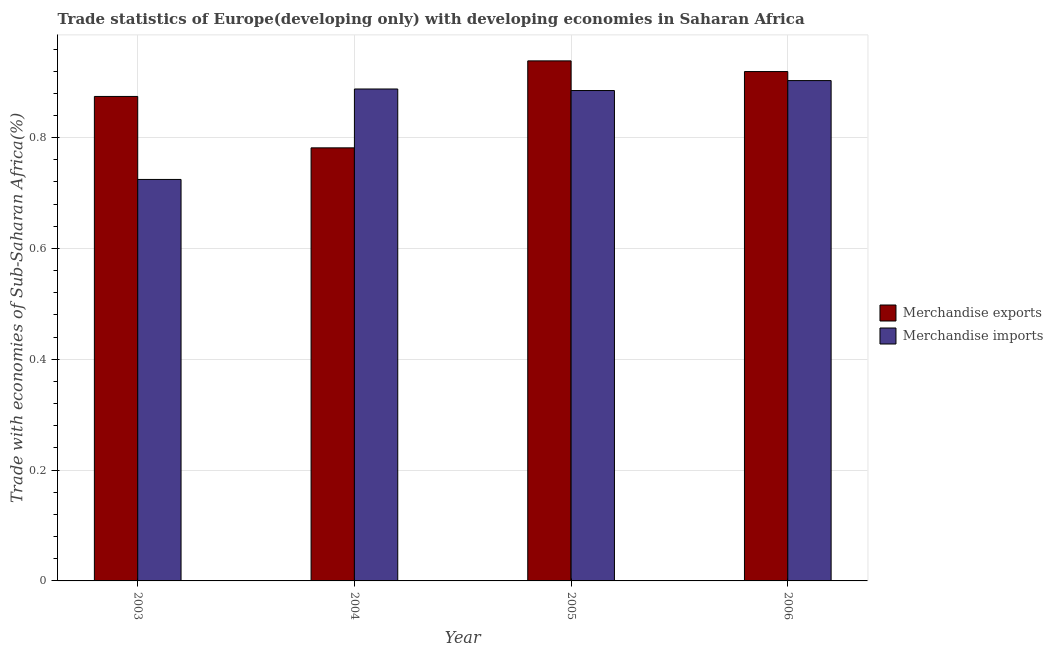How many groups of bars are there?
Provide a succinct answer. 4. Are the number of bars per tick equal to the number of legend labels?
Offer a very short reply. Yes. What is the merchandise imports in 2004?
Provide a succinct answer. 0.89. Across all years, what is the maximum merchandise exports?
Offer a very short reply. 0.94. Across all years, what is the minimum merchandise imports?
Ensure brevity in your answer.  0.72. What is the total merchandise exports in the graph?
Offer a very short reply. 3.51. What is the difference between the merchandise imports in 2004 and that in 2006?
Offer a terse response. -0.02. What is the difference between the merchandise exports in 2003 and the merchandise imports in 2004?
Provide a succinct answer. 0.09. What is the average merchandise exports per year?
Give a very brief answer. 0.88. In the year 2005, what is the difference between the merchandise exports and merchandise imports?
Make the answer very short. 0. What is the ratio of the merchandise exports in 2003 to that in 2005?
Provide a succinct answer. 0.93. Is the merchandise imports in 2005 less than that in 2006?
Your answer should be compact. Yes. What is the difference between the highest and the second highest merchandise exports?
Your answer should be very brief. 0.02. What is the difference between the highest and the lowest merchandise exports?
Your answer should be compact. 0.16. In how many years, is the merchandise imports greater than the average merchandise imports taken over all years?
Provide a short and direct response. 3. Is the sum of the merchandise exports in 2003 and 2004 greater than the maximum merchandise imports across all years?
Your answer should be very brief. Yes. What does the 2nd bar from the left in 2003 represents?
Provide a short and direct response. Merchandise imports. What does the 2nd bar from the right in 2004 represents?
Make the answer very short. Merchandise exports. Are all the bars in the graph horizontal?
Offer a very short reply. No. How many years are there in the graph?
Provide a succinct answer. 4. Does the graph contain grids?
Ensure brevity in your answer.  Yes. How many legend labels are there?
Your answer should be very brief. 2. What is the title of the graph?
Provide a short and direct response. Trade statistics of Europe(developing only) with developing economies in Saharan Africa. What is the label or title of the X-axis?
Make the answer very short. Year. What is the label or title of the Y-axis?
Offer a terse response. Trade with economies of Sub-Saharan Africa(%). What is the Trade with economies of Sub-Saharan Africa(%) of Merchandise exports in 2003?
Provide a succinct answer. 0.87. What is the Trade with economies of Sub-Saharan Africa(%) in Merchandise imports in 2003?
Provide a short and direct response. 0.72. What is the Trade with economies of Sub-Saharan Africa(%) in Merchandise exports in 2004?
Make the answer very short. 0.78. What is the Trade with economies of Sub-Saharan Africa(%) in Merchandise imports in 2004?
Provide a succinct answer. 0.89. What is the Trade with economies of Sub-Saharan Africa(%) of Merchandise exports in 2005?
Provide a succinct answer. 0.94. What is the Trade with economies of Sub-Saharan Africa(%) in Merchandise imports in 2005?
Your answer should be compact. 0.89. What is the Trade with economies of Sub-Saharan Africa(%) of Merchandise exports in 2006?
Give a very brief answer. 0.92. What is the Trade with economies of Sub-Saharan Africa(%) in Merchandise imports in 2006?
Your response must be concise. 0.9. Across all years, what is the maximum Trade with economies of Sub-Saharan Africa(%) in Merchandise exports?
Make the answer very short. 0.94. Across all years, what is the maximum Trade with economies of Sub-Saharan Africa(%) in Merchandise imports?
Offer a terse response. 0.9. Across all years, what is the minimum Trade with economies of Sub-Saharan Africa(%) in Merchandise exports?
Your response must be concise. 0.78. Across all years, what is the minimum Trade with economies of Sub-Saharan Africa(%) of Merchandise imports?
Make the answer very short. 0.72. What is the total Trade with economies of Sub-Saharan Africa(%) in Merchandise exports in the graph?
Provide a short and direct response. 3.51. What is the total Trade with economies of Sub-Saharan Africa(%) of Merchandise imports in the graph?
Your answer should be compact. 3.4. What is the difference between the Trade with economies of Sub-Saharan Africa(%) in Merchandise exports in 2003 and that in 2004?
Your response must be concise. 0.09. What is the difference between the Trade with economies of Sub-Saharan Africa(%) of Merchandise imports in 2003 and that in 2004?
Keep it short and to the point. -0.16. What is the difference between the Trade with economies of Sub-Saharan Africa(%) in Merchandise exports in 2003 and that in 2005?
Your answer should be compact. -0.06. What is the difference between the Trade with economies of Sub-Saharan Africa(%) in Merchandise imports in 2003 and that in 2005?
Your response must be concise. -0.16. What is the difference between the Trade with economies of Sub-Saharan Africa(%) of Merchandise exports in 2003 and that in 2006?
Give a very brief answer. -0.04. What is the difference between the Trade with economies of Sub-Saharan Africa(%) in Merchandise imports in 2003 and that in 2006?
Offer a terse response. -0.18. What is the difference between the Trade with economies of Sub-Saharan Africa(%) in Merchandise exports in 2004 and that in 2005?
Make the answer very short. -0.16. What is the difference between the Trade with economies of Sub-Saharan Africa(%) in Merchandise imports in 2004 and that in 2005?
Ensure brevity in your answer.  0. What is the difference between the Trade with economies of Sub-Saharan Africa(%) in Merchandise exports in 2004 and that in 2006?
Your answer should be compact. -0.14. What is the difference between the Trade with economies of Sub-Saharan Africa(%) in Merchandise imports in 2004 and that in 2006?
Provide a succinct answer. -0.02. What is the difference between the Trade with economies of Sub-Saharan Africa(%) of Merchandise exports in 2005 and that in 2006?
Give a very brief answer. 0.02. What is the difference between the Trade with economies of Sub-Saharan Africa(%) of Merchandise imports in 2005 and that in 2006?
Offer a terse response. -0.02. What is the difference between the Trade with economies of Sub-Saharan Africa(%) of Merchandise exports in 2003 and the Trade with economies of Sub-Saharan Africa(%) of Merchandise imports in 2004?
Provide a short and direct response. -0.01. What is the difference between the Trade with economies of Sub-Saharan Africa(%) in Merchandise exports in 2003 and the Trade with economies of Sub-Saharan Africa(%) in Merchandise imports in 2005?
Offer a terse response. -0.01. What is the difference between the Trade with economies of Sub-Saharan Africa(%) in Merchandise exports in 2003 and the Trade with economies of Sub-Saharan Africa(%) in Merchandise imports in 2006?
Offer a terse response. -0.03. What is the difference between the Trade with economies of Sub-Saharan Africa(%) in Merchandise exports in 2004 and the Trade with economies of Sub-Saharan Africa(%) in Merchandise imports in 2005?
Provide a succinct answer. -0.1. What is the difference between the Trade with economies of Sub-Saharan Africa(%) in Merchandise exports in 2004 and the Trade with economies of Sub-Saharan Africa(%) in Merchandise imports in 2006?
Your answer should be compact. -0.12. What is the difference between the Trade with economies of Sub-Saharan Africa(%) of Merchandise exports in 2005 and the Trade with economies of Sub-Saharan Africa(%) of Merchandise imports in 2006?
Offer a terse response. 0.04. What is the average Trade with economies of Sub-Saharan Africa(%) in Merchandise exports per year?
Your answer should be very brief. 0.88. What is the average Trade with economies of Sub-Saharan Africa(%) in Merchandise imports per year?
Provide a short and direct response. 0.85. In the year 2003, what is the difference between the Trade with economies of Sub-Saharan Africa(%) in Merchandise exports and Trade with economies of Sub-Saharan Africa(%) in Merchandise imports?
Your response must be concise. 0.15. In the year 2004, what is the difference between the Trade with economies of Sub-Saharan Africa(%) in Merchandise exports and Trade with economies of Sub-Saharan Africa(%) in Merchandise imports?
Make the answer very short. -0.11. In the year 2005, what is the difference between the Trade with economies of Sub-Saharan Africa(%) in Merchandise exports and Trade with economies of Sub-Saharan Africa(%) in Merchandise imports?
Provide a short and direct response. 0.05. In the year 2006, what is the difference between the Trade with economies of Sub-Saharan Africa(%) of Merchandise exports and Trade with economies of Sub-Saharan Africa(%) of Merchandise imports?
Provide a succinct answer. 0.02. What is the ratio of the Trade with economies of Sub-Saharan Africa(%) in Merchandise exports in 2003 to that in 2004?
Give a very brief answer. 1.12. What is the ratio of the Trade with economies of Sub-Saharan Africa(%) of Merchandise imports in 2003 to that in 2004?
Your answer should be compact. 0.82. What is the ratio of the Trade with economies of Sub-Saharan Africa(%) of Merchandise exports in 2003 to that in 2005?
Your answer should be very brief. 0.93. What is the ratio of the Trade with economies of Sub-Saharan Africa(%) of Merchandise imports in 2003 to that in 2005?
Keep it short and to the point. 0.82. What is the ratio of the Trade with economies of Sub-Saharan Africa(%) of Merchandise exports in 2003 to that in 2006?
Offer a very short reply. 0.95. What is the ratio of the Trade with economies of Sub-Saharan Africa(%) of Merchandise imports in 2003 to that in 2006?
Offer a terse response. 0.8. What is the ratio of the Trade with economies of Sub-Saharan Africa(%) of Merchandise exports in 2004 to that in 2005?
Make the answer very short. 0.83. What is the ratio of the Trade with economies of Sub-Saharan Africa(%) in Merchandise imports in 2004 to that in 2005?
Your answer should be very brief. 1. What is the ratio of the Trade with economies of Sub-Saharan Africa(%) in Merchandise exports in 2004 to that in 2006?
Ensure brevity in your answer.  0.85. What is the ratio of the Trade with economies of Sub-Saharan Africa(%) of Merchandise imports in 2004 to that in 2006?
Offer a very short reply. 0.98. What is the ratio of the Trade with economies of Sub-Saharan Africa(%) of Merchandise imports in 2005 to that in 2006?
Offer a very short reply. 0.98. What is the difference between the highest and the second highest Trade with economies of Sub-Saharan Africa(%) of Merchandise exports?
Your response must be concise. 0.02. What is the difference between the highest and the second highest Trade with economies of Sub-Saharan Africa(%) in Merchandise imports?
Provide a short and direct response. 0.02. What is the difference between the highest and the lowest Trade with economies of Sub-Saharan Africa(%) of Merchandise exports?
Provide a short and direct response. 0.16. What is the difference between the highest and the lowest Trade with economies of Sub-Saharan Africa(%) in Merchandise imports?
Offer a terse response. 0.18. 